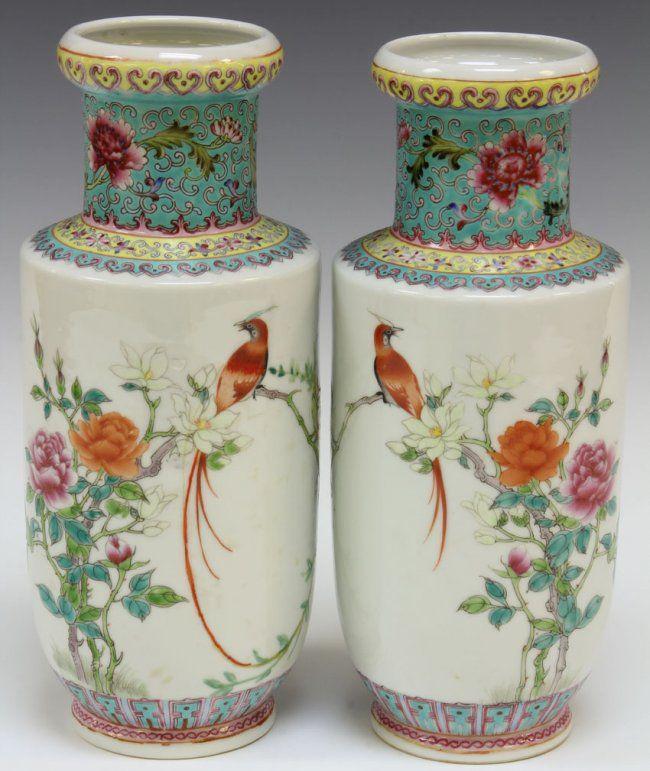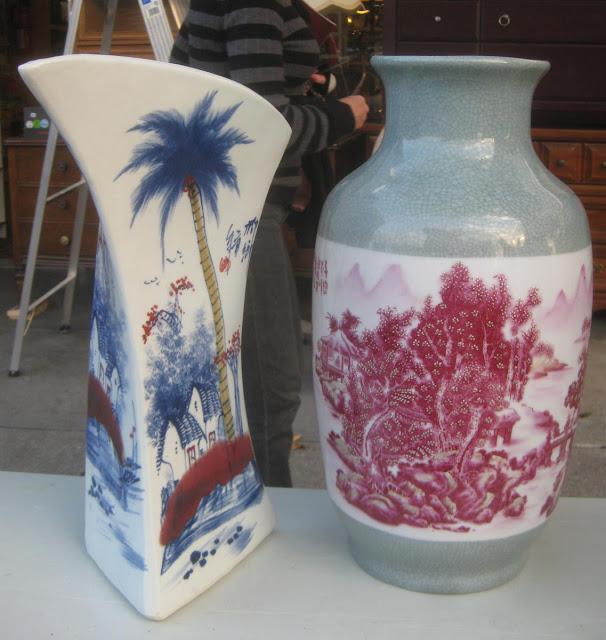The first image is the image on the left, the second image is the image on the right. Analyze the images presented: Is the assertion "There are flowers in a vase in the image on the left." valid? Answer yes or no. No. 